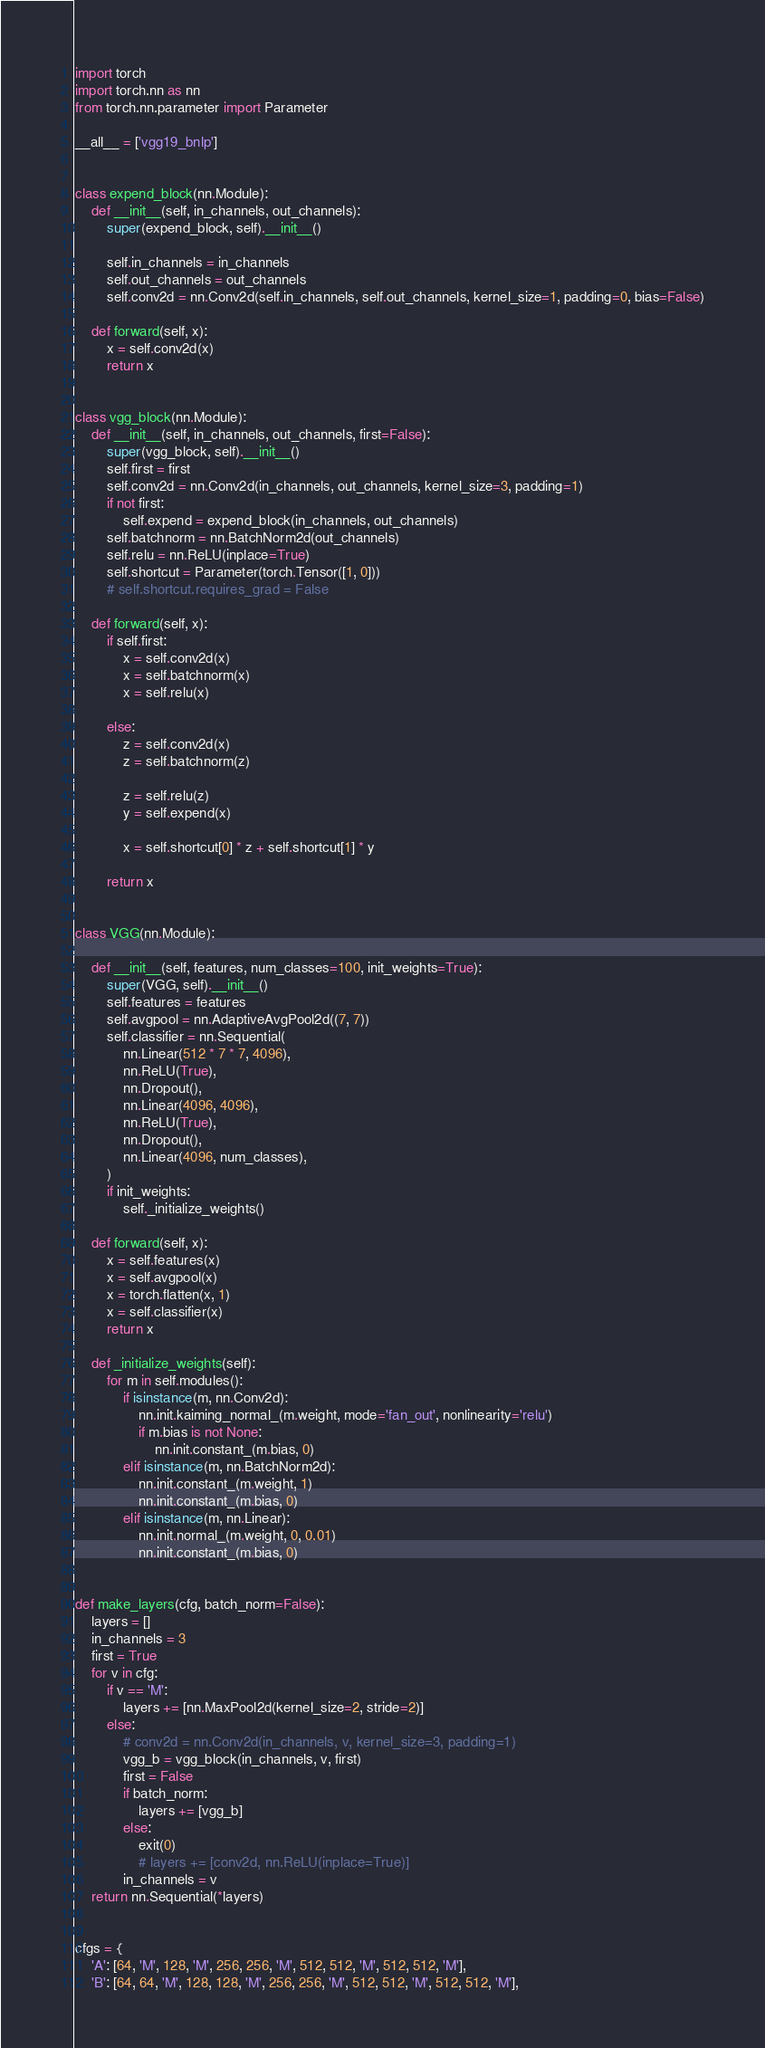Convert code to text. <code><loc_0><loc_0><loc_500><loc_500><_Python_>import torch
import torch.nn as nn
from torch.nn.parameter import Parameter

__all__ = ['vgg19_bnlp']


class expend_block(nn.Module):
    def __init__(self, in_channels, out_channels):
        super(expend_block, self).__init__()

        self.in_channels = in_channels
        self.out_channels = out_channels
        self.conv2d = nn.Conv2d(self.in_channels, self.out_channels, kernel_size=1, padding=0, bias=False)

    def forward(self, x):
        x = self.conv2d(x)
        return x


class vgg_block(nn.Module):
    def __init__(self, in_channels, out_channels, first=False):
        super(vgg_block, self).__init__()
        self.first = first
        self.conv2d = nn.Conv2d(in_channels, out_channels, kernel_size=3, padding=1)
        if not first:
            self.expend = expend_block(in_channels, out_channels)
        self.batchnorm = nn.BatchNorm2d(out_channels)
        self.relu = nn.ReLU(inplace=True)
        self.shortcut = Parameter(torch.Tensor([1, 0]))
        # self.shortcut.requires_grad = False

    def forward(self, x):
        if self.first:
            x = self.conv2d(x)
            x = self.batchnorm(x)
            x = self.relu(x)

        else:
            z = self.conv2d(x)
            z = self.batchnorm(z)

            z = self.relu(z)
            y = self.expend(x)

            x = self.shortcut[0] * z + self.shortcut[1] * y

        return x


class VGG(nn.Module):

    def __init__(self, features, num_classes=100, init_weights=True):
        super(VGG, self).__init__()
        self.features = features
        self.avgpool = nn.AdaptiveAvgPool2d((7, 7))
        self.classifier = nn.Sequential(
            nn.Linear(512 * 7 * 7, 4096),
            nn.ReLU(True),
            nn.Dropout(),
            nn.Linear(4096, 4096),
            nn.ReLU(True),
            nn.Dropout(),
            nn.Linear(4096, num_classes),
        )
        if init_weights:
            self._initialize_weights()

    def forward(self, x):
        x = self.features(x)
        x = self.avgpool(x)
        x = torch.flatten(x, 1)
        x = self.classifier(x)
        return x

    def _initialize_weights(self):
        for m in self.modules():
            if isinstance(m, nn.Conv2d):
                nn.init.kaiming_normal_(m.weight, mode='fan_out', nonlinearity='relu')
                if m.bias is not None:
                    nn.init.constant_(m.bias, 0)
            elif isinstance(m, nn.BatchNorm2d):
                nn.init.constant_(m.weight, 1)
                nn.init.constant_(m.bias, 0)
            elif isinstance(m, nn.Linear):
                nn.init.normal_(m.weight, 0, 0.01)
                nn.init.constant_(m.bias, 0)


def make_layers(cfg, batch_norm=False):
    layers = []
    in_channels = 3
    first = True
    for v in cfg:
        if v == 'M':
            layers += [nn.MaxPool2d(kernel_size=2, stride=2)]
        else:
            # conv2d = nn.Conv2d(in_channels, v, kernel_size=3, padding=1)
            vgg_b = vgg_block(in_channels, v, first)
            first = False
            if batch_norm:
                layers += [vgg_b]
            else:
                exit(0)
                # layers += [conv2d, nn.ReLU(inplace=True)]
            in_channels = v
    return nn.Sequential(*layers)


cfgs = {
    'A': [64, 'M', 128, 'M', 256, 256, 'M', 512, 512, 'M', 512, 512, 'M'],
    'B': [64, 64, 'M', 128, 128, 'M', 256, 256, 'M', 512, 512, 'M', 512, 512, 'M'],</code> 